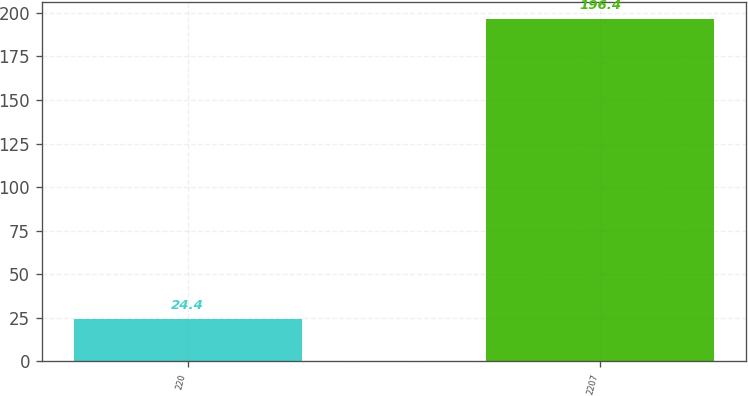Convert chart to OTSL. <chart><loc_0><loc_0><loc_500><loc_500><bar_chart><fcel>220<fcel>2207<nl><fcel>24.4<fcel>196.4<nl></chart> 